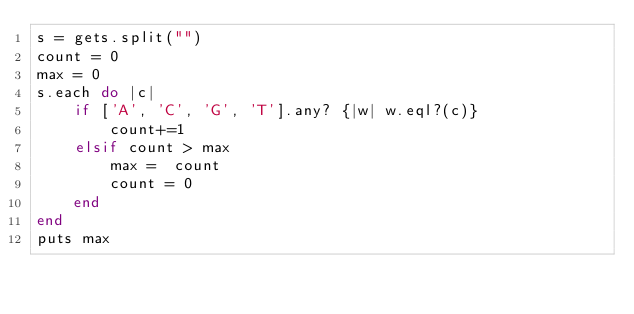Convert code to text. <code><loc_0><loc_0><loc_500><loc_500><_Ruby_>s = gets.split("")
count = 0
max = 0
s.each do |c|
    if ['A', 'C', 'G', 'T'].any? {|w| w.eql?(c)}
        count+=1
    elsif count > max
        max =  count
        count = 0
    end
end
puts max</code> 